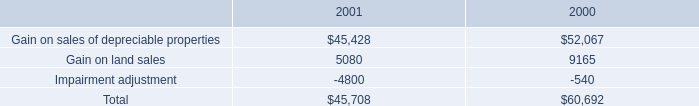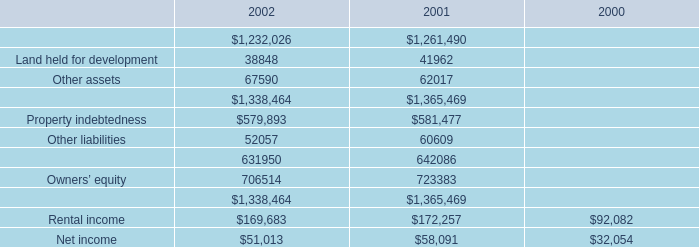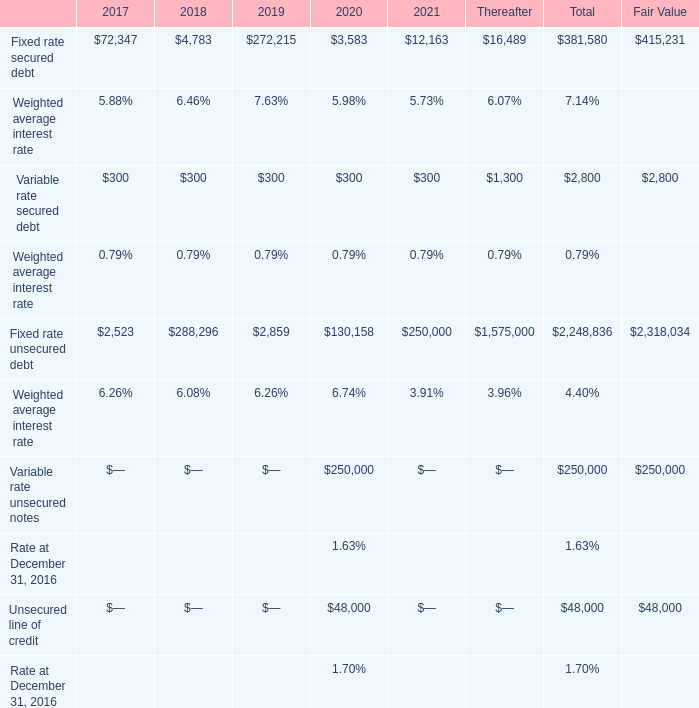What's the average of Other assets of 2002, and Gain on sales of depreciable properties of 2001 ? 
Computations: ((67590.0 + 45428.0) / 2)
Answer: 56509.0. 